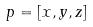Convert formula to latex. <formula><loc_0><loc_0><loc_500><loc_500>p = [ x , y , z ]</formula> 